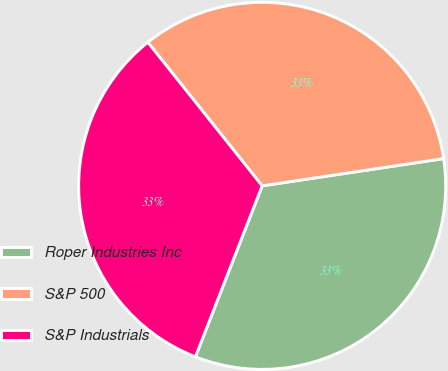<chart> <loc_0><loc_0><loc_500><loc_500><pie_chart><fcel>Roper Industries Inc<fcel>S&P 500<fcel>S&P Industrials<nl><fcel>33.3%<fcel>33.33%<fcel>33.37%<nl></chart> 